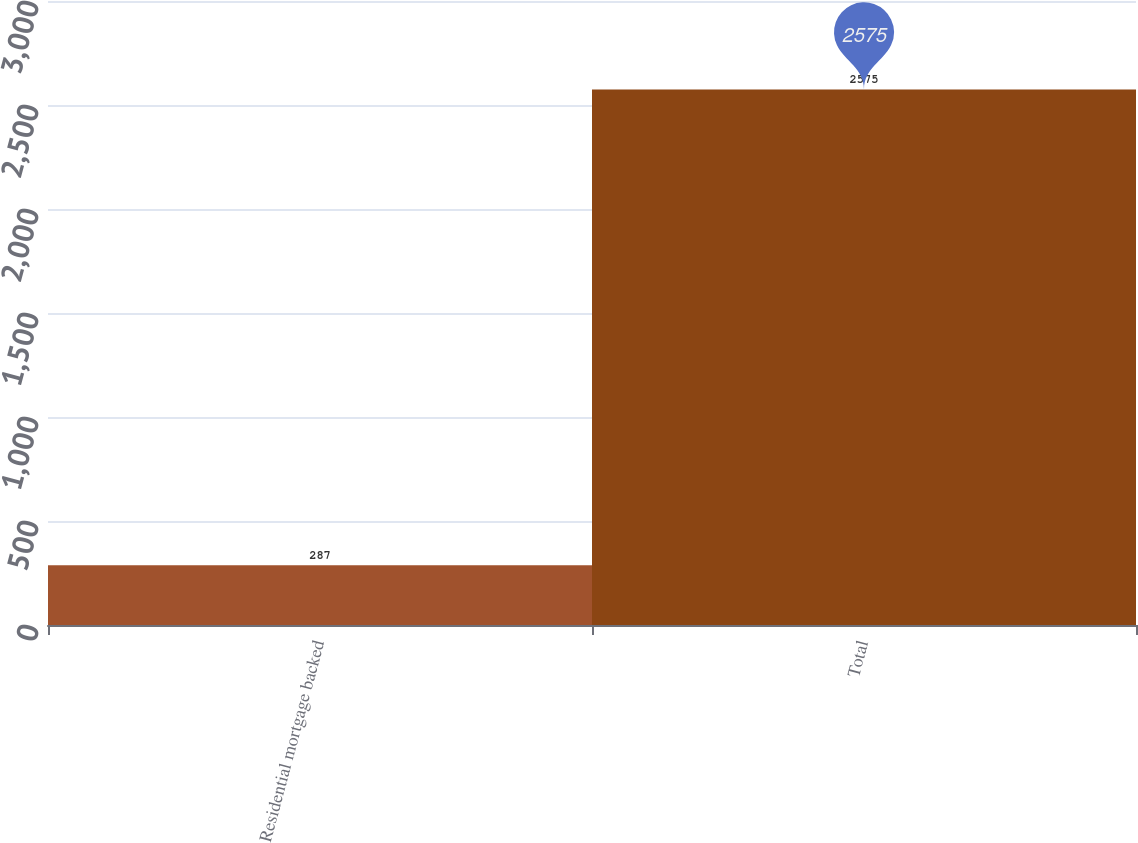Convert chart. <chart><loc_0><loc_0><loc_500><loc_500><bar_chart><fcel>Residential mortgage backed<fcel>Total<nl><fcel>287<fcel>2575<nl></chart> 